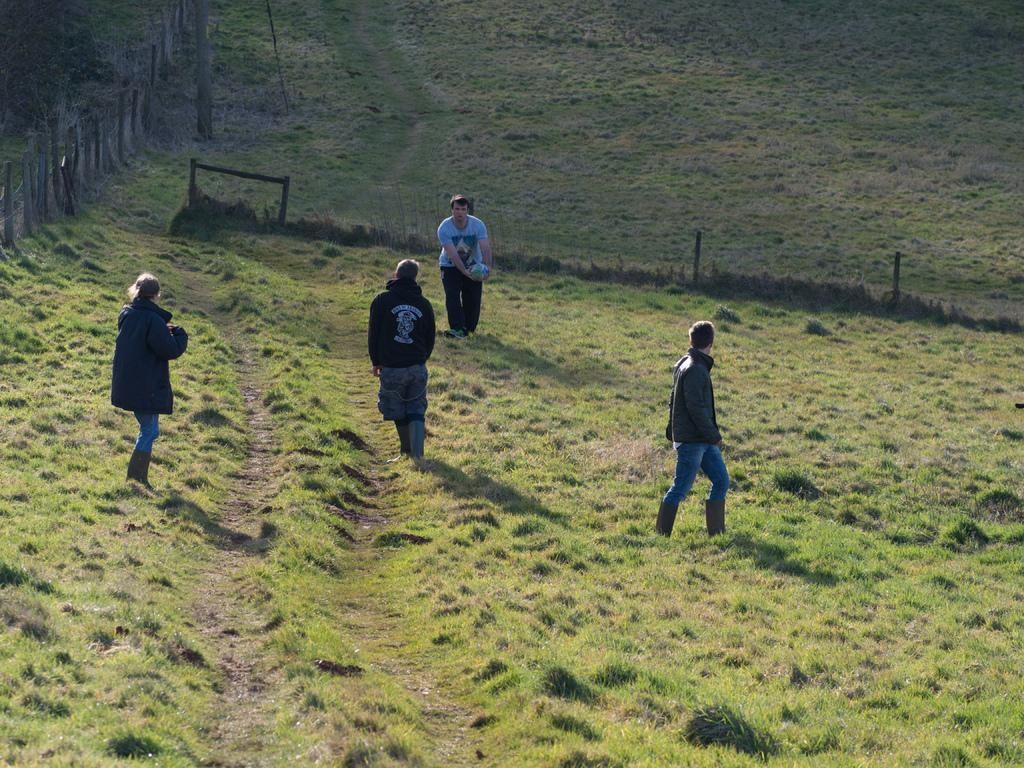How many people are in the image? There are people in the image, but the exact number is not specified. What is the man holding in the image? The man is holding a ball in the image. What type of natural environment is visible in the background of the image? There is grass in the background of the image. What architectural or structural elements can be seen in the background of the image? There is a fence and wooden poles in the background of the image. What type of pain is the man experiencing while holding the ball in the image? There is no indication in the image that the man is experiencing any pain, so it cannot be determined from the picture. 